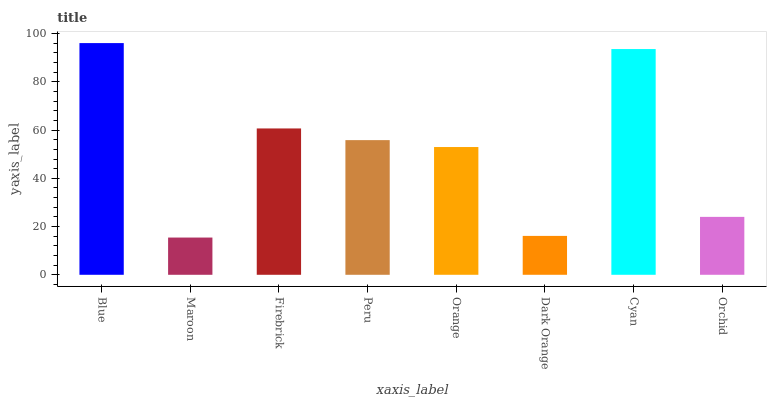Is Maroon the minimum?
Answer yes or no. Yes. Is Blue the maximum?
Answer yes or no. Yes. Is Firebrick the minimum?
Answer yes or no. No. Is Firebrick the maximum?
Answer yes or no. No. Is Firebrick greater than Maroon?
Answer yes or no. Yes. Is Maroon less than Firebrick?
Answer yes or no. Yes. Is Maroon greater than Firebrick?
Answer yes or no. No. Is Firebrick less than Maroon?
Answer yes or no. No. Is Peru the high median?
Answer yes or no. Yes. Is Orange the low median?
Answer yes or no. Yes. Is Firebrick the high median?
Answer yes or no. No. Is Maroon the low median?
Answer yes or no. No. 